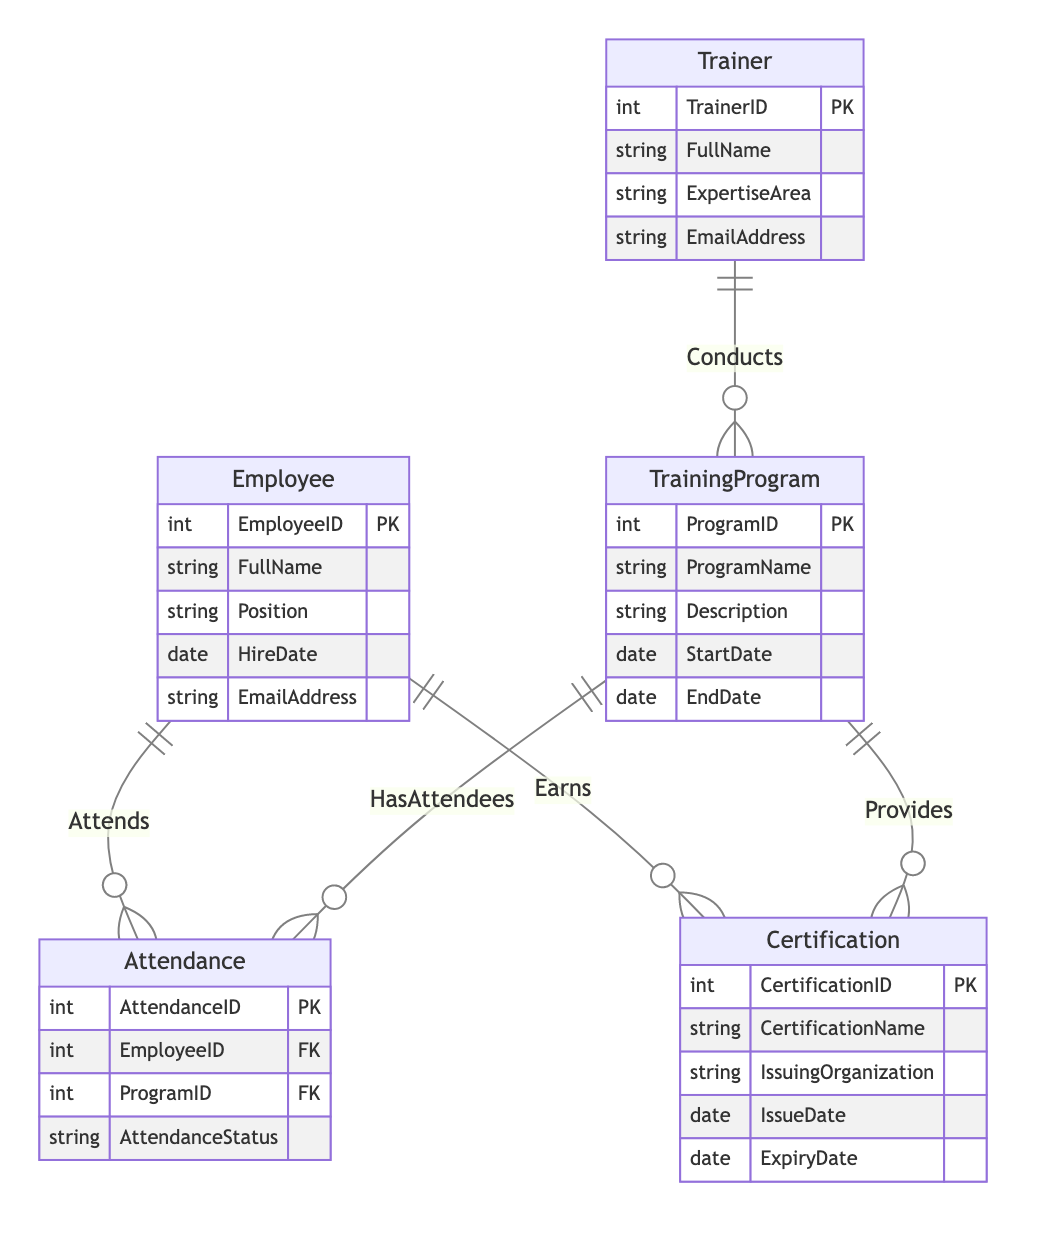What is the primary entity in this diagram? The primary entity is typically represented by a rectangle that does not have outgoing relationships to other entities, indicating that it is the focal point of the diagram. In this case, the primary entity is Employee.
Answer: Employee How many relationships are shown in the diagram? The relationships are represented by the lines connecting the different entities. There are four relationships shown: Attends, Conducts, Earns, and Provides.
Answer: Four What relationship connects Employee and TrainingProgram? The relationship that connects Employee and TrainingProgram is named "Attends." This indicates that employees attend training programs.
Answer: Attends What does the Trainer entity represent in the diagram? The Trainer entity represents individuals who are responsible for conducting training programs, indicated by the relationship with the TrainingProgram entity.
Answer: Conducts Which entity provides certifications? The entity that provides certifications to employees is the TrainingProgram, as indicated by the relationship labeled "Provides." This means that certain training programs enable employees to earn certifications.
Answer: TrainingProgram How many attributes does the Trainer entity have? The Trainer entity has four attributes: TrainerID, FullName, ExpertiseArea, and EmailAddress.
Answer: Four What indicates that an Employee has earned a Certification? The relationship labeled "Earns" indicates that an Employee has earned a Certification, meaning there exists a connection from Employee to Certification through this relationship.
Answer: Earns Which entities are connected by the 'Provides' relationship? The 'Provides' relationship connects the TrainingProgram entity to the Certification entity, indicating that training programs offer specific certifications.
Answer: TrainingProgram, Certification How is an employee's attendance status recorded? An employee's attendance status is recorded in the Attendance entity, which includes the AttendanceID, EmployeeID, ProgramID, and AttendanceStatus attributes.
Answer: Attendance entity 